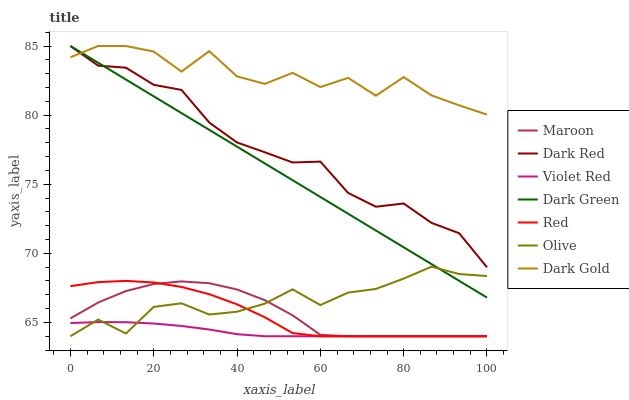Does Violet Red have the minimum area under the curve?
Answer yes or no. Yes. Does Dark Gold have the maximum area under the curve?
Answer yes or no. Yes. Does Dark Red have the minimum area under the curve?
Answer yes or no. No. Does Dark Red have the maximum area under the curve?
Answer yes or no. No. Is Dark Green the smoothest?
Answer yes or no. Yes. Is Dark Gold the roughest?
Answer yes or no. Yes. Is Dark Red the smoothest?
Answer yes or no. No. Is Dark Red the roughest?
Answer yes or no. No. Does Dark Red have the lowest value?
Answer yes or no. No. Does Maroon have the highest value?
Answer yes or no. No. Is Olive less than Dark Red?
Answer yes or no. Yes. Is Dark Red greater than Violet Red?
Answer yes or no. Yes. Does Olive intersect Dark Red?
Answer yes or no. No. 